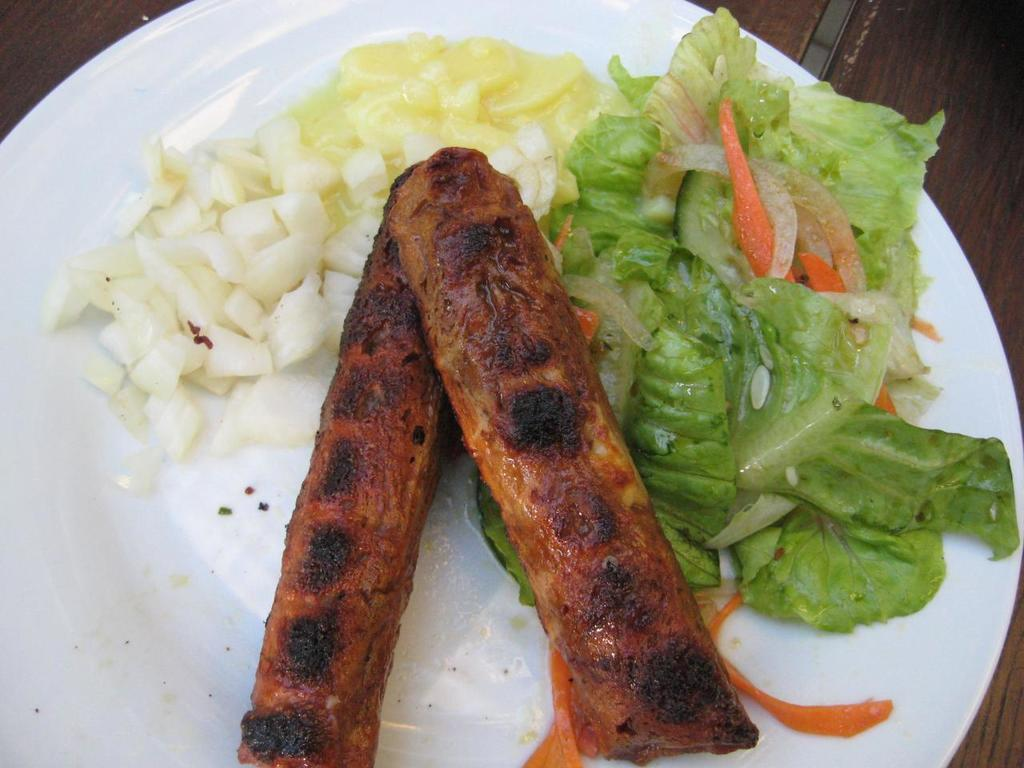What is in the center of the image? There is a plate in the center of the image. What is on the plate? The plate contains vegetables and meat. Where is the plate located? The plate is placed on a table. How many ghosts are sitting around the table in the image? There are no ghosts present in the image. What type of apples are being served on the plate? There are no apples present on the plate; it contains vegetables and meat. 